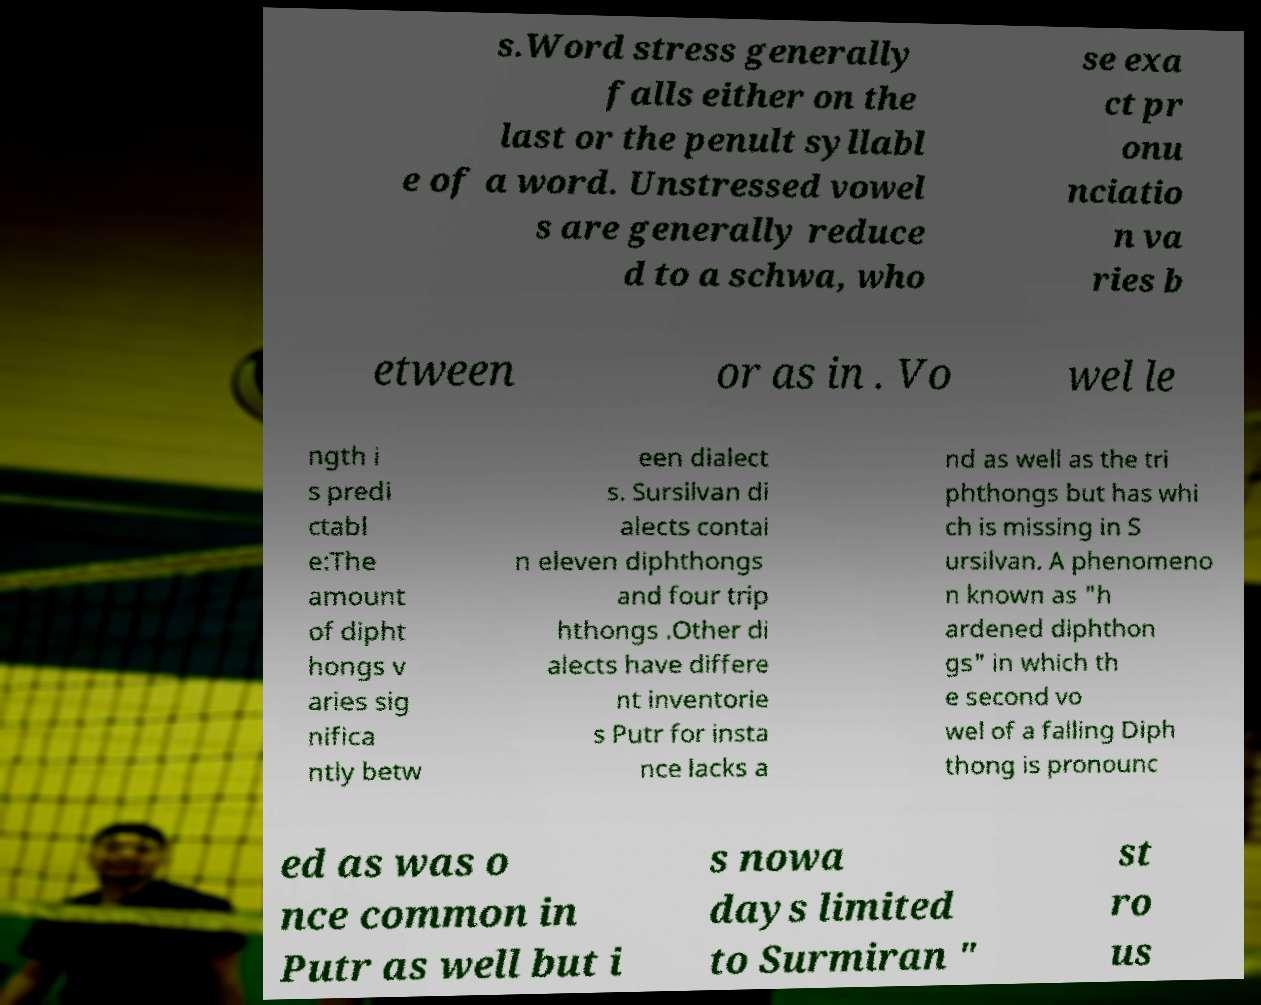Please read and relay the text visible in this image. What does it say? s.Word stress generally falls either on the last or the penult syllabl e of a word. Unstressed vowel s are generally reduce d to a schwa, who se exa ct pr onu nciatio n va ries b etween or as in . Vo wel le ngth i s predi ctabl e:The amount of dipht hongs v aries sig nifica ntly betw een dialect s. Sursilvan di alects contai n eleven diphthongs and four trip hthongs .Other di alects have differe nt inventorie s Putr for insta nce lacks a nd as well as the tri phthongs but has whi ch is missing in S ursilvan. A phenomeno n known as "h ardened diphthon gs" in which th e second vo wel of a falling Diph thong is pronounc ed as was o nce common in Putr as well but i s nowa days limited to Surmiran " st ro us 